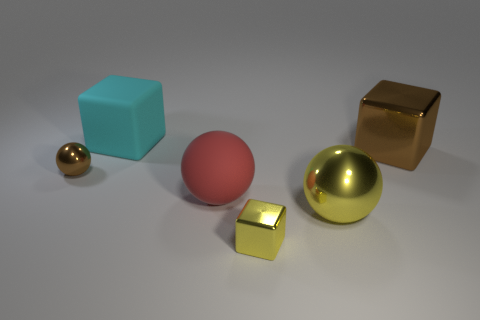What is the material of the thing that is the same color as the tiny metal block?
Keep it short and to the point. Metal. There is a sphere that is the same color as the large metallic block; what size is it?
Provide a succinct answer. Small. What number of objects are either big yellow metallic balls or big metallic objects that are left of the big brown object?
Offer a very short reply. 1. How many other things are there of the same shape as the cyan object?
Keep it short and to the point. 2. Are there fewer big brown metal things that are behind the tiny shiny ball than yellow blocks to the left of the large red rubber object?
Your response must be concise. No. Is there anything else that is the same material as the yellow block?
Ensure brevity in your answer.  Yes. The other large thing that is the same material as the cyan object is what shape?
Make the answer very short. Sphere. Are there any other things that are the same color as the large metal cube?
Your answer should be compact. Yes. There is a small shiny object behind the large thing that is in front of the large red thing; what is its color?
Keep it short and to the point. Brown. There is a large cube on the right side of the tiny metallic thing that is on the right side of the large thing to the left of the rubber sphere; what is it made of?
Make the answer very short. Metal. 